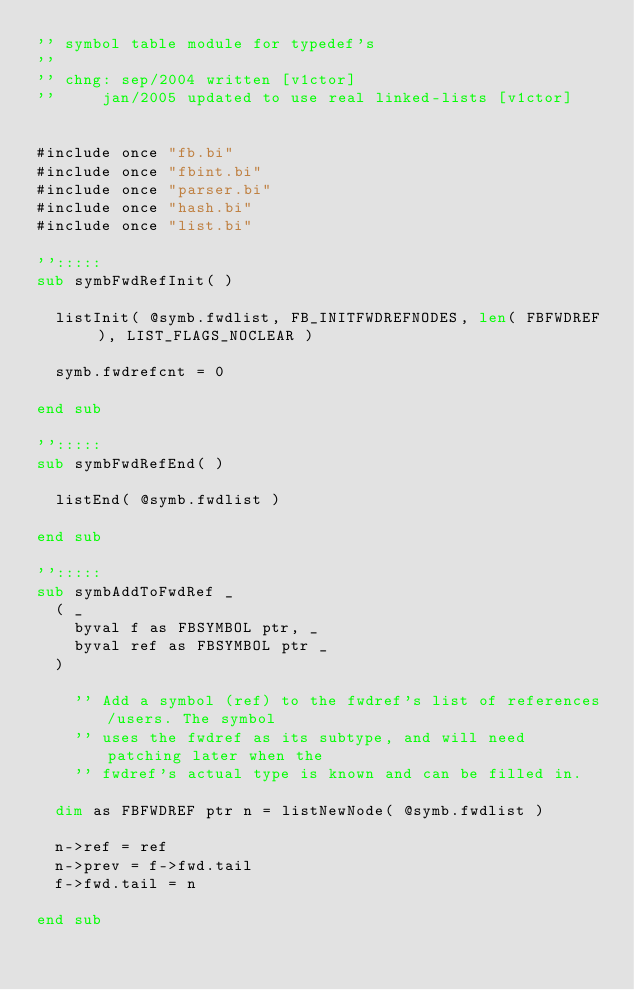Convert code to text. <code><loc_0><loc_0><loc_500><loc_500><_VisualBasic_>'' symbol table module for typedef's
''
'' chng: sep/2004 written [v1ctor]
''		 jan/2005 updated to use real linked-lists [v1ctor]


#include once "fb.bi"
#include once "fbint.bi"
#include once "parser.bi"
#include once "hash.bi"
#include once "list.bi"

'':::::
sub symbFwdRefInit( )

	listInit( @symb.fwdlist, FB_INITFWDREFNODES, len( FBFWDREF ), LIST_FLAGS_NOCLEAR )

	symb.fwdrefcnt = 0

end sub

'':::::
sub symbFwdRefEnd( )

	listEnd( @symb.fwdlist )

end sub

'':::::
sub symbAddToFwdRef _
	( _
		byval f as FBSYMBOL ptr, _
		byval ref as FBSYMBOL ptr _
	)

    '' Add a symbol (ref) to the fwdref's list of references/users. The symbol
    '' uses the fwdref as its subtype, and will need patching later when the
    '' fwdref's actual type is known and can be filled in.

	dim as FBFWDREF ptr n = listNewNode( @symb.fwdlist )

	n->ref = ref
	n->prev = f->fwd.tail
	f->fwd.tail = n

end sub
</code> 